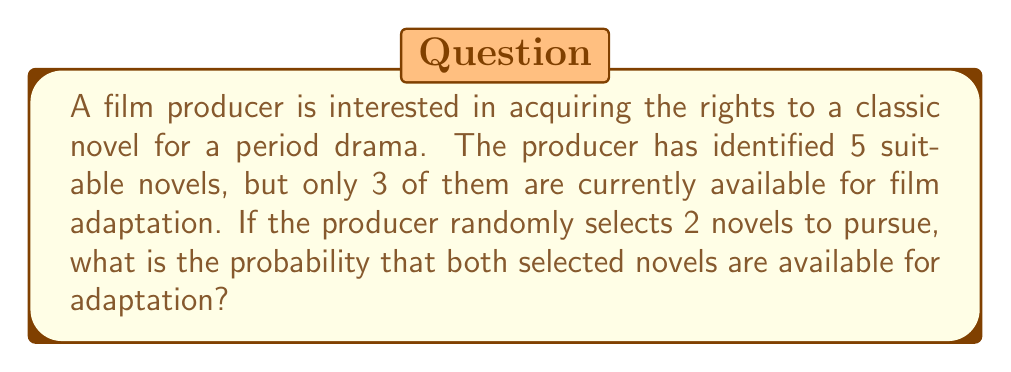Teach me how to tackle this problem. To solve this problem, we can use the concept of conditional probability and the multiplication rule.

Let's break it down step by step:

1. Total number of novels: 5
2. Number of available novels: 3
3. Number of novels to be selected: 2

We need to calculate the probability of selecting 2 available novels out of the 3 available ones, given that we are selecting 2 out of 5 total novels.

Step 1: Probability of selecting the first available novel
$$P(\text{First novel available}) = \frac{3}{5}$$

Step 2: Probability of selecting the second available novel, given that the first one was available
$$P(\text{Second novel available | First novel available}) = \frac{2}{4}$$

Step 3: Apply the multiplication rule to find the probability of both events occurring
$$P(\text{Both novels available}) = P(\text{First novel available}) \times P(\text{Second novel available | First novel available})$$

$$P(\text{Both novels available}) = \frac{3}{5} \times \frac{2}{4}$$

Step 4: Simplify the fraction
$$P(\text{Both novels available}) = \frac{3}{5} \times \frac{1}{2} = \frac{3}{10}$$

Therefore, the probability of selecting two novels that are both available for adaptation is $\frac{3}{10}$ or 0.3 or 30%.
Answer: $\frac{3}{10}$ or 0.3 or 30% 